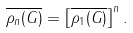<formula> <loc_0><loc_0><loc_500><loc_500>\overline { \rho _ { n } ( G ) } = \left [ \overline { \rho _ { 1 } ( G ) } \right ] ^ { n } .</formula> 